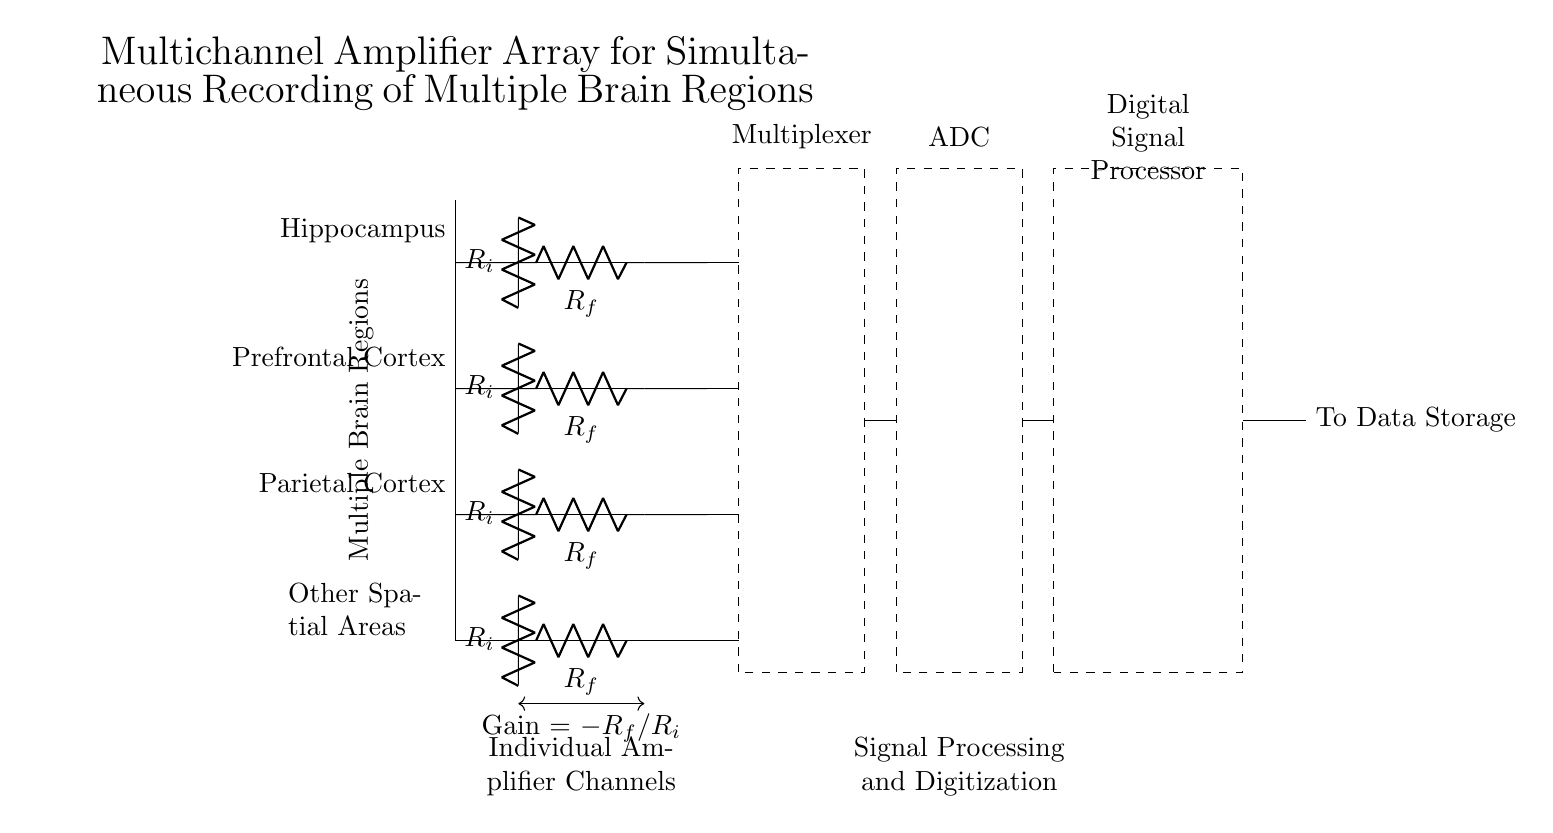What regions are being recorded? The circuit includes input channels labeled as Hippocampus, Prefrontal Cortex, Parietal Cortex, and Other Spatial Areas, indicating the regions involved in the recordings.
Answer: Hippocampus, Prefrontal Cortex, Parietal Cortex, Other Spatial Areas What component is responsible for gain control? The gain control is represented by the ratio of resistors \( R_f \) and \( R_i \) connected in the feedback path of the amplifier. Gain is calculated using the formula Gain = -\( R_f/R_i \), which determines the amplification factor for the input signals.
Answer: Gain = -R_f/R_i How many channels are there for amplification? The diagram shows four distinct input channels, suggesting simultaneous amplification of signals from each of these brain regions.
Answer: Four What type of signal processing occurs after amplification? The signal undergoes digitization and processing after being passed through an Analog to Digital Converter (ADC) in the circuit, indicating transformation from analog signals to digital signals for further analysis.
Answer: Digitization What is the purpose of the multiplexer in the circuit? The multiplexer aggregates signals from multiple channels and allows selection of one channel at a time, facilitating streamlined data processing and ensuring precise data acquisition from the chosen brain region.
Answer: Channel selection What is the function of the Digital Signal Processor? The Digital Signal Processor (DSP) processes the digital signals after conversion from the ADC, performing computations and analyses necessary for the research into spatial and narrative processing in brain regions.
Answer: Signal processing What is depicted within the dashed rectangles in the circuit? The dashed rectangles represent different functional blocks: the multiplexer, the ADC, and the DSP, each responsible for specific operations in the signal acquisition and processing workflow.
Answer: Functional blocks 